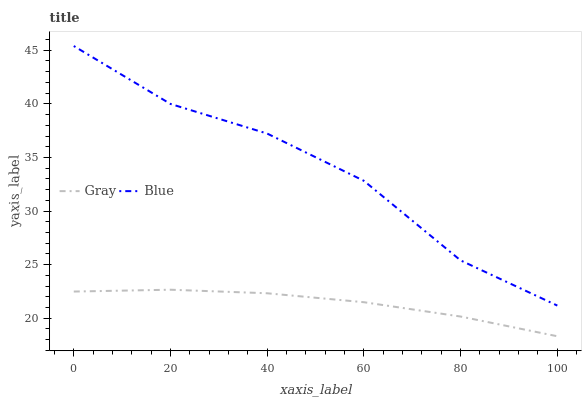Does Gray have the maximum area under the curve?
Answer yes or no. No. Is Gray the roughest?
Answer yes or no. No. Does Gray have the highest value?
Answer yes or no. No. Is Gray less than Blue?
Answer yes or no. Yes. Is Blue greater than Gray?
Answer yes or no. Yes. Does Gray intersect Blue?
Answer yes or no. No. 